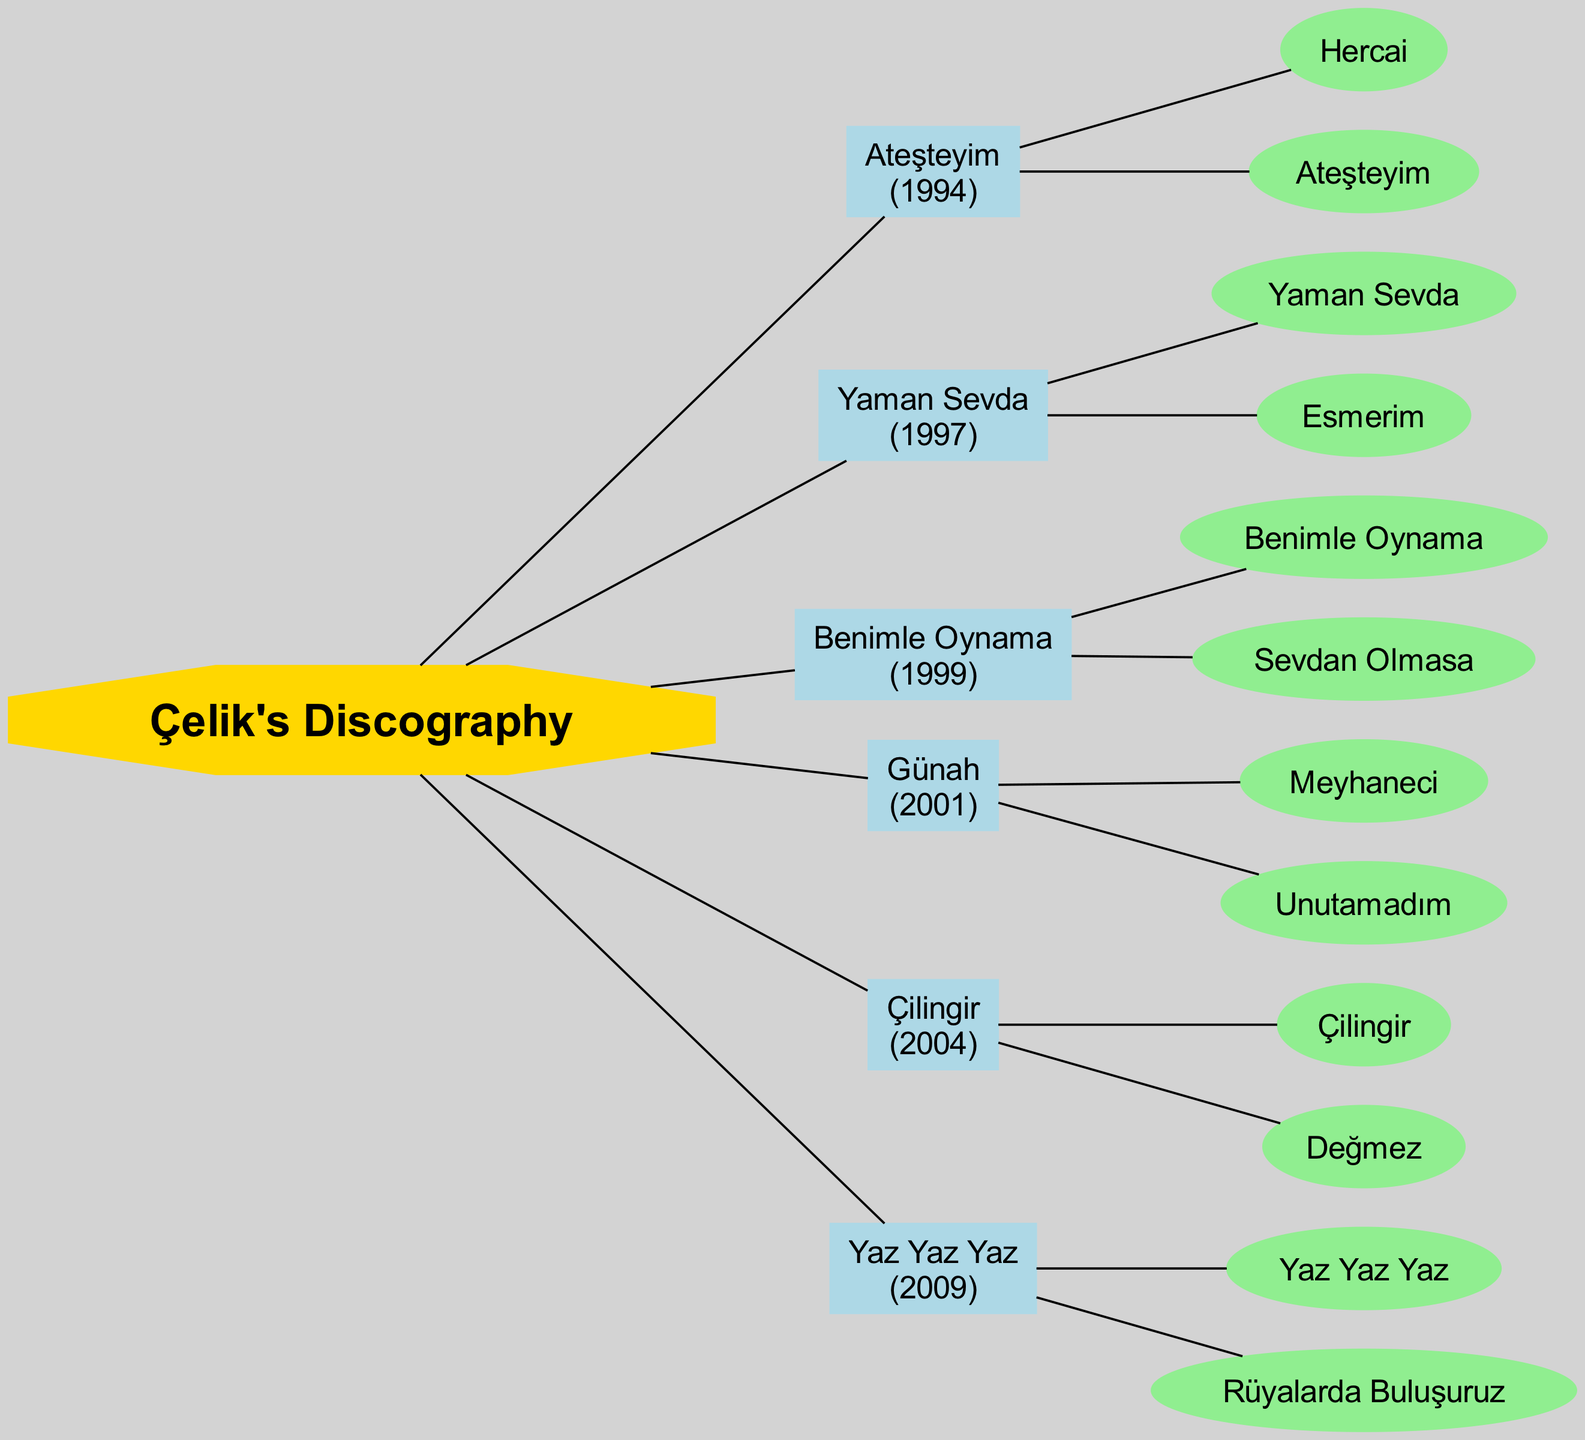What is the first album in Çelik's discography? The diagram lists the albums in chronological order of their release years. The first album is at the top left location of the diagram, which is "Ateşteyim".
Answer: Ateşteyim How many notable songs are included in the album "Günah"? The diagram shows a direct connection from the album "Günah" to its notable songs. By counting the songs listed under this album, we find there are two notable songs: "Meyhaneci" and "Unutamadım".
Answer: 2 Which album was released in 2009? The diagram has the albums connected sequentially by year. The album located at the bottom right, which shows the year 2009, is "Yaz Yaz Yaz".
Answer: Yaz Yaz Yaz What are the notable songs from the album "Yaman Sevda"? The diagram connects the album "Yaman Sevda" to its notable songs. Reading directly from the diagram, the notable songs are "Yaman Sevda" and "Esmerim".
Answer: Yaman Sevda, Esmerim In total, how many albums are listed in Çelik's discography? The total count of albums can be derived by counting the distinct album nodes in the diagram. There are six album nodes shown in the diagram.
Answer: 6 Among the albums, which one contains the song "Benimle Oynama"? By checking each album listed in the diagram for the song mentioned, we find the album that contains "Benimle Oynama" is "Benimle Oynama", which is connected directly to that song in the diagram.
Answer: Benimle Oynama Which album features "Çilingir" as a notable song? The diagram indicates which notable songs belong to which albums. Looking for "Çilingir" reveals that it is a notable song under the album titled "Çilingir".
Answer: Çilingir What is the common year of release for the albums "Ateşteyim" and "Günah"? The diagram shows the release years of each album. "Ateşteyim" is in 1994 and "Günah" is in 2001. Since the question asks for a common year between them, a direct answer would be that there is no common year.
Answer: None 